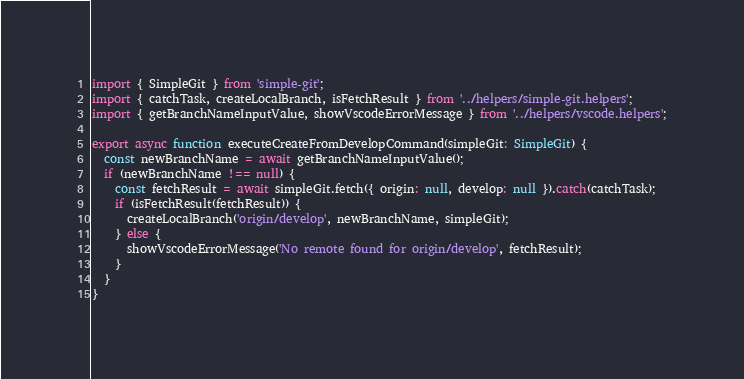Convert code to text. <code><loc_0><loc_0><loc_500><loc_500><_TypeScript_>import { SimpleGit } from 'simple-git';
import { catchTask, createLocalBranch, isFetchResult } from '../helpers/simple-git.helpers';
import { getBranchNameInputValue, showVscodeErrorMessage } from '../helpers/vscode.helpers';

export async function executeCreateFromDevelopCommand(simpleGit: SimpleGit) {
  const newBranchName = await getBranchNameInputValue();
  if (newBranchName !== null) {
    const fetchResult = await simpleGit.fetch({ origin: null, develop: null }).catch(catchTask);
    if (isFetchResult(fetchResult)) {
      createLocalBranch('origin/develop', newBranchName, simpleGit);
    } else {
      showVscodeErrorMessage('No remote found for origin/develop', fetchResult);
    }
  }
}
</code> 